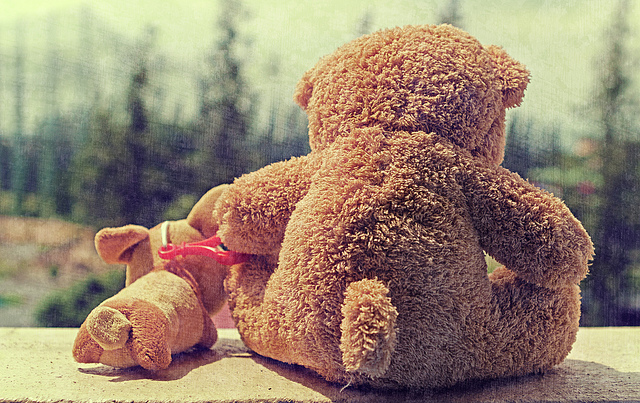How many teddy bears? 1 